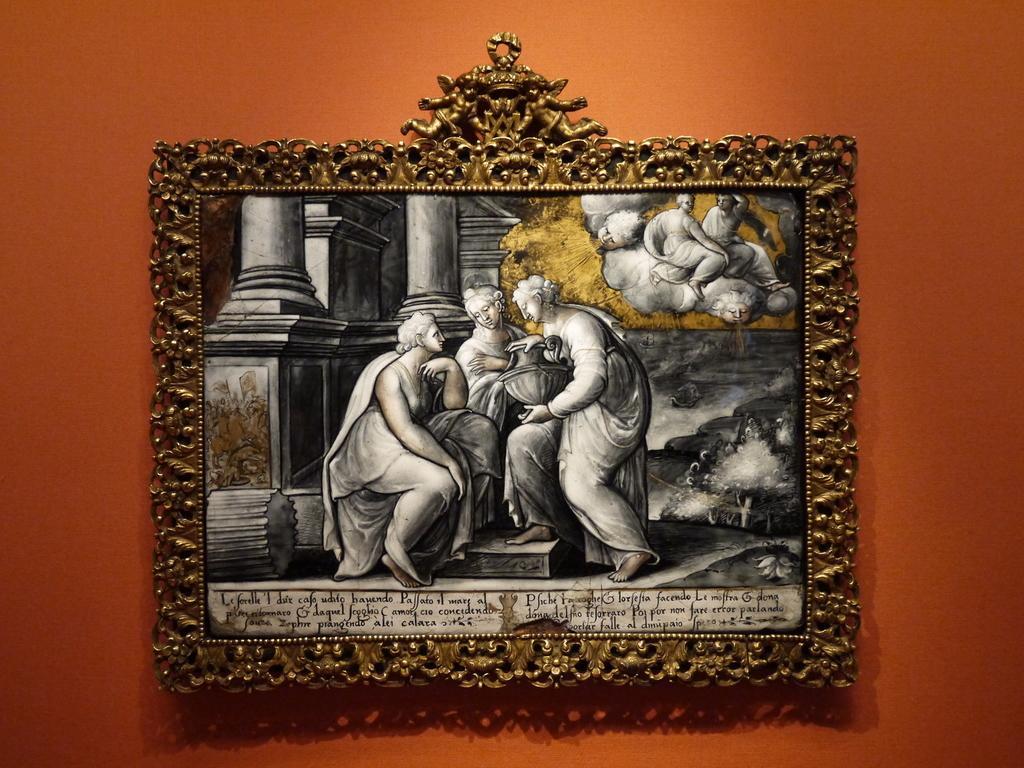In one or two sentences, can you explain what this image depicts? In the center of the image we can see a frame attached to the plain orange color wall and on the frame we can see some persons. We can also see the text at the bottom of the frame. 